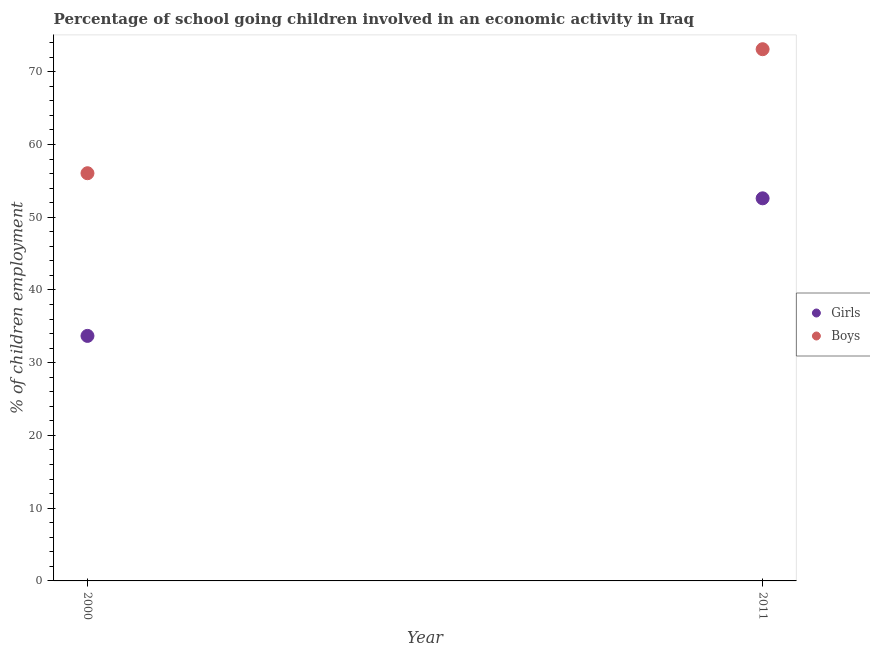Is the number of dotlines equal to the number of legend labels?
Give a very brief answer. Yes. What is the percentage of school going girls in 2011?
Make the answer very short. 52.6. Across all years, what is the maximum percentage of school going girls?
Offer a terse response. 52.6. Across all years, what is the minimum percentage of school going girls?
Ensure brevity in your answer.  33.69. In which year was the percentage of school going girls maximum?
Offer a terse response. 2011. What is the total percentage of school going boys in the graph?
Keep it short and to the point. 129.15. What is the difference between the percentage of school going girls in 2000 and that in 2011?
Keep it short and to the point. -18.91. What is the difference between the percentage of school going boys in 2011 and the percentage of school going girls in 2000?
Provide a succinct answer. 39.41. What is the average percentage of school going girls per year?
Make the answer very short. 43.14. In the year 2011, what is the difference between the percentage of school going boys and percentage of school going girls?
Ensure brevity in your answer.  20.5. In how many years, is the percentage of school going boys greater than 72 %?
Provide a succinct answer. 1. What is the ratio of the percentage of school going boys in 2000 to that in 2011?
Offer a very short reply. 0.77. Is the percentage of school going boys in 2000 less than that in 2011?
Your answer should be very brief. Yes. In how many years, is the percentage of school going boys greater than the average percentage of school going boys taken over all years?
Ensure brevity in your answer.  1. Does the percentage of school going girls monotonically increase over the years?
Ensure brevity in your answer.  Yes. How many dotlines are there?
Your response must be concise. 2. What is the difference between two consecutive major ticks on the Y-axis?
Your answer should be very brief. 10. Does the graph contain any zero values?
Make the answer very short. No. Does the graph contain grids?
Your answer should be very brief. No. Where does the legend appear in the graph?
Provide a short and direct response. Center right. How are the legend labels stacked?
Ensure brevity in your answer.  Vertical. What is the title of the graph?
Your answer should be compact. Percentage of school going children involved in an economic activity in Iraq. What is the label or title of the Y-axis?
Your answer should be compact. % of children employment. What is the % of children employment in Girls in 2000?
Provide a short and direct response. 33.69. What is the % of children employment of Boys in 2000?
Make the answer very short. 56.05. What is the % of children employment of Girls in 2011?
Provide a short and direct response. 52.6. What is the % of children employment in Boys in 2011?
Your response must be concise. 73.1. Across all years, what is the maximum % of children employment of Girls?
Keep it short and to the point. 52.6. Across all years, what is the maximum % of children employment of Boys?
Ensure brevity in your answer.  73.1. Across all years, what is the minimum % of children employment of Girls?
Provide a short and direct response. 33.69. Across all years, what is the minimum % of children employment in Boys?
Offer a very short reply. 56.05. What is the total % of children employment in Girls in the graph?
Offer a very short reply. 86.29. What is the total % of children employment of Boys in the graph?
Your answer should be very brief. 129.15. What is the difference between the % of children employment in Girls in 2000 and that in 2011?
Offer a very short reply. -18.91. What is the difference between the % of children employment in Boys in 2000 and that in 2011?
Your answer should be compact. -17.05. What is the difference between the % of children employment of Girls in 2000 and the % of children employment of Boys in 2011?
Keep it short and to the point. -39.41. What is the average % of children employment of Girls per year?
Provide a short and direct response. 43.14. What is the average % of children employment in Boys per year?
Give a very brief answer. 64.58. In the year 2000, what is the difference between the % of children employment of Girls and % of children employment of Boys?
Ensure brevity in your answer.  -22.36. In the year 2011, what is the difference between the % of children employment in Girls and % of children employment in Boys?
Give a very brief answer. -20.5. What is the ratio of the % of children employment of Girls in 2000 to that in 2011?
Offer a terse response. 0.64. What is the ratio of the % of children employment of Boys in 2000 to that in 2011?
Provide a succinct answer. 0.77. What is the difference between the highest and the second highest % of children employment of Girls?
Your answer should be compact. 18.91. What is the difference between the highest and the second highest % of children employment of Boys?
Give a very brief answer. 17.05. What is the difference between the highest and the lowest % of children employment of Girls?
Offer a very short reply. 18.91. What is the difference between the highest and the lowest % of children employment in Boys?
Make the answer very short. 17.05. 